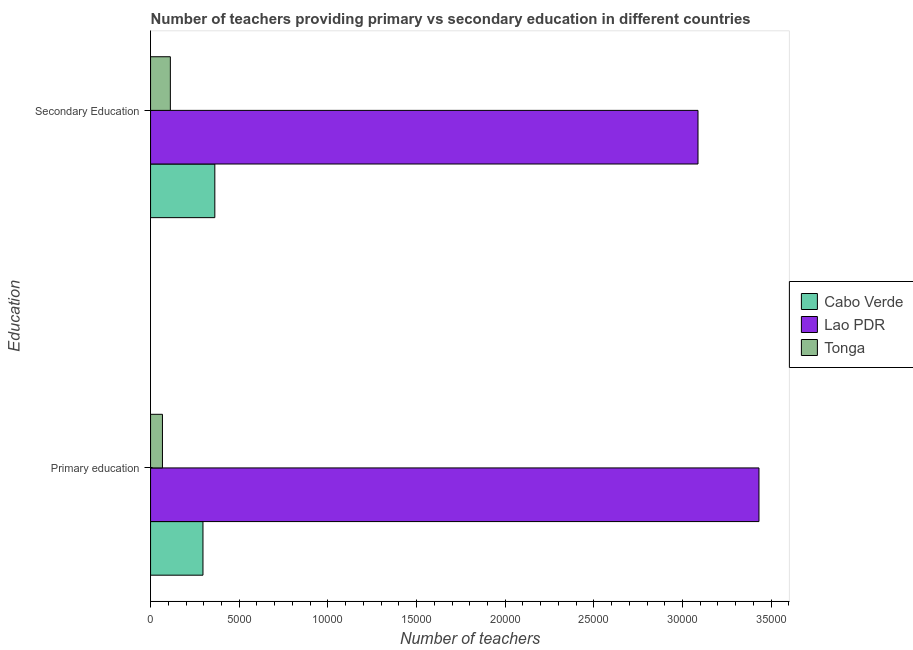How many different coloured bars are there?
Your answer should be compact. 3. How many groups of bars are there?
Your answer should be compact. 2. How many bars are there on the 2nd tick from the bottom?
Offer a very short reply. 3. What is the label of the 2nd group of bars from the top?
Your response must be concise. Primary education. What is the number of secondary teachers in Tonga?
Keep it short and to the point. 1116. Across all countries, what is the maximum number of secondary teachers?
Make the answer very short. 3.09e+04. Across all countries, what is the minimum number of secondary teachers?
Keep it short and to the point. 1116. In which country was the number of primary teachers maximum?
Offer a very short reply. Lao PDR. In which country was the number of secondary teachers minimum?
Ensure brevity in your answer.  Tonga. What is the total number of secondary teachers in the graph?
Ensure brevity in your answer.  3.56e+04. What is the difference between the number of secondary teachers in Cabo Verde and that in Tonga?
Your answer should be compact. 2508. What is the difference between the number of primary teachers in Tonga and the number of secondary teachers in Cabo Verde?
Offer a very short reply. -2954. What is the average number of primary teachers per country?
Offer a very short reply. 1.26e+04. What is the difference between the number of secondary teachers and number of primary teachers in Cabo Verde?
Offer a very short reply. 669. In how many countries, is the number of primary teachers greater than 18000 ?
Provide a short and direct response. 1. What is the ratio of the number of primary teachers in Lao PDR to that in Cabo Verde?
Your answer should be compact. 11.61. What does the 3rd bar from the top in Secondary Education represents?
Offer a terse response. Cabo Verde. What does the 1st bar from the bottom in Primary education represents?
Provide a short and direct response. Cabo Verde. How many bars are there?
Make the answer very short. 6. Are all the bars in the graph horizontal?
Offer a very short reply. Yes. How many countries are there in the graph?
Provide a succinct answer. 3. How are the legend labels stacked?
Provide a succinct answer. Vertical. What is the title of the graph?
Make the answer very short. Number of teachers providing primary vs secondary education in different countries. Does "Trinidad and Tobago" appear as one of the legend labels in the graph?
Your answer should be compact. No. What is the label or title of the X-axis?
Offer a terse response. Number of teachers. What is the label or title of the Y-axis?
Keep it short and to the point. Education. What is the Number of teachers in Cabo Verde in Primary education?
Offer a very short reply. 2955. What is the Number of teachers in Lao PDR in Primary education?
Your answer should be very brief. 3.43e+04. What is the Number of teachers of Tonga in Primary education?
Keep it short and to the point. 670. What is the Number of teachers in Cabo Verde in Secondary Education?
Your answer should be compact. 3624. What is the Number of teachers of Lao PDR in Secondary Education?
Keep it short and to the point. 3.09e+04. What is the Number of teachers in Tonga in Secondary Education?
Offer a very short reply. 1116. Across all Education, what is the maximum Number of teachers in Cabo Verde?
Your response must be concise. 3624. Across all Education, what is the maximum Number of teachers of Lao PDR?
Your answer should be compact. 3.43e+04. Across all Education, what is the maximum Number of teachers in Tonga?
Provide a short and direct response. 1116. Across all Education, what is the minimum Number of teachers of Cabo Verde?
Make the answer very short. 2955. Across all Education, what is the minimum Number of teachers of Lao PDR?
Your answer should be very brief. 3.09e+04. Across all Education, what is the minimum Number of teachers in Tonga?
Provide a succinct answer. 670. What is the total Number of teachers of Cabo Verde in the graph?
Your response must be concise. 6579. What is the total Number of teachers in Lao PDR in the graph?
Give a very brief answer. 6.52e+04. What is the total Number of teachers of Tonga in the graph?
Give a very brief answer. 1786. What is the difference between the Number of teachers in Cabo Verde in Primary education and that in Secondary Education?
Ensure brevity in your answer.  -669. What is the difference between the Number of teachers of Lao PDR in Primary education and that in Secondary Education?
Your answer should be compact. 3438. What is the difference between the Number of teachers in Tonga in Primary education and that in Secondary Education?
Your response must be concise. -446. What is the difference between the Number of teachers in Cabo Verde in Primary education and the Number of teachers in Lao PDR in Secondary Education?
Keep it short and to the point. -2.79e+04. What is the difference between the Number of teachers of Cabo Verde in Primary education and the Number of teachers of Tonga in Secondary Education?
Make the answer very short. 1839. What is the difference between the Number of teachers in Lao PDR in Primary education and the Number of teachers in Tonga in Secondary Education?
Ensure brevity in your answer.  3.32e+04. What is the average Number of teachers of Cabo Verde per Education?
Ensure brevity in your answer.  3289.5. What is the average Number of teachers in Lao PDR per Education?
Make the answer very short. 3.26e+04. What is the average Number of teachers of Tonga per Education?
Provide a short and direct response. 893. What is the difference between the Number of teachers in Cabo Verde and Number of teachers in Lao PDR in Primary education?
Make the answer very short. -3.14e+04. What is the difference between the Number of teachers of Cabo Verde and Number of teachers of Tonga in Primary education?
Give a very brief answer. 2285. What is the difference between the Number of teachers in Lao PDR and Number of teachers in Tonga in Primary education?
Provide a short and direct response. 3.36e+04. What is the difference between the Number of teachers of Cabo Verde and Number of teachers of Lao PDR in Secondary Education?
Provide a short and direct response. -2.72e+04. What is the difference between the Number of teachers in Cabo Verde and Number of teachers in Tonga in Secondary Education?
Offer a terse response. 2508. What is the difference between the Number of teachers in Lao PDR and Number of teachers in Tonga in Secondary Education?
Ensure brevity in your answer.  2.98e+04. What is the ratio of the Number of teachers in Cabo Verde in Primary education to that in Secondary Education?
Keep it short and to the point. 0.82. What is the ratio of the Number of teachers in Lao PDR in Primary education to that in Secondary Education?
Provide a short and direct response. 1.11. What is the ratio of the Number of teachers of Tonga in Primary education to that in Secondary Education?
Give a very brief answer. 0.6. What is the difference between the highest and the second highest Number of teachers in Cabo Verde?
Offer a very short reply. 669. What is the difference between the highest and the second highest Number of teachers of Lao PDR?
Provide a short and direct response. 3438. What is the difference between the highest and the second highest Number of teachers in Tonga?
Your answer should be compact. 446. What is the difference between the highest and the lowest Number of teachers of Cabo Verde?
Offer a very short reply. 669. What is the difference between the highest and the lowest Number of teachers in Lao PDR?
Provide a short and direct response. 3438. What is the difference between the highest and the lowest Number of teachers in Tonga?
Provide a short and direct response. 446. 